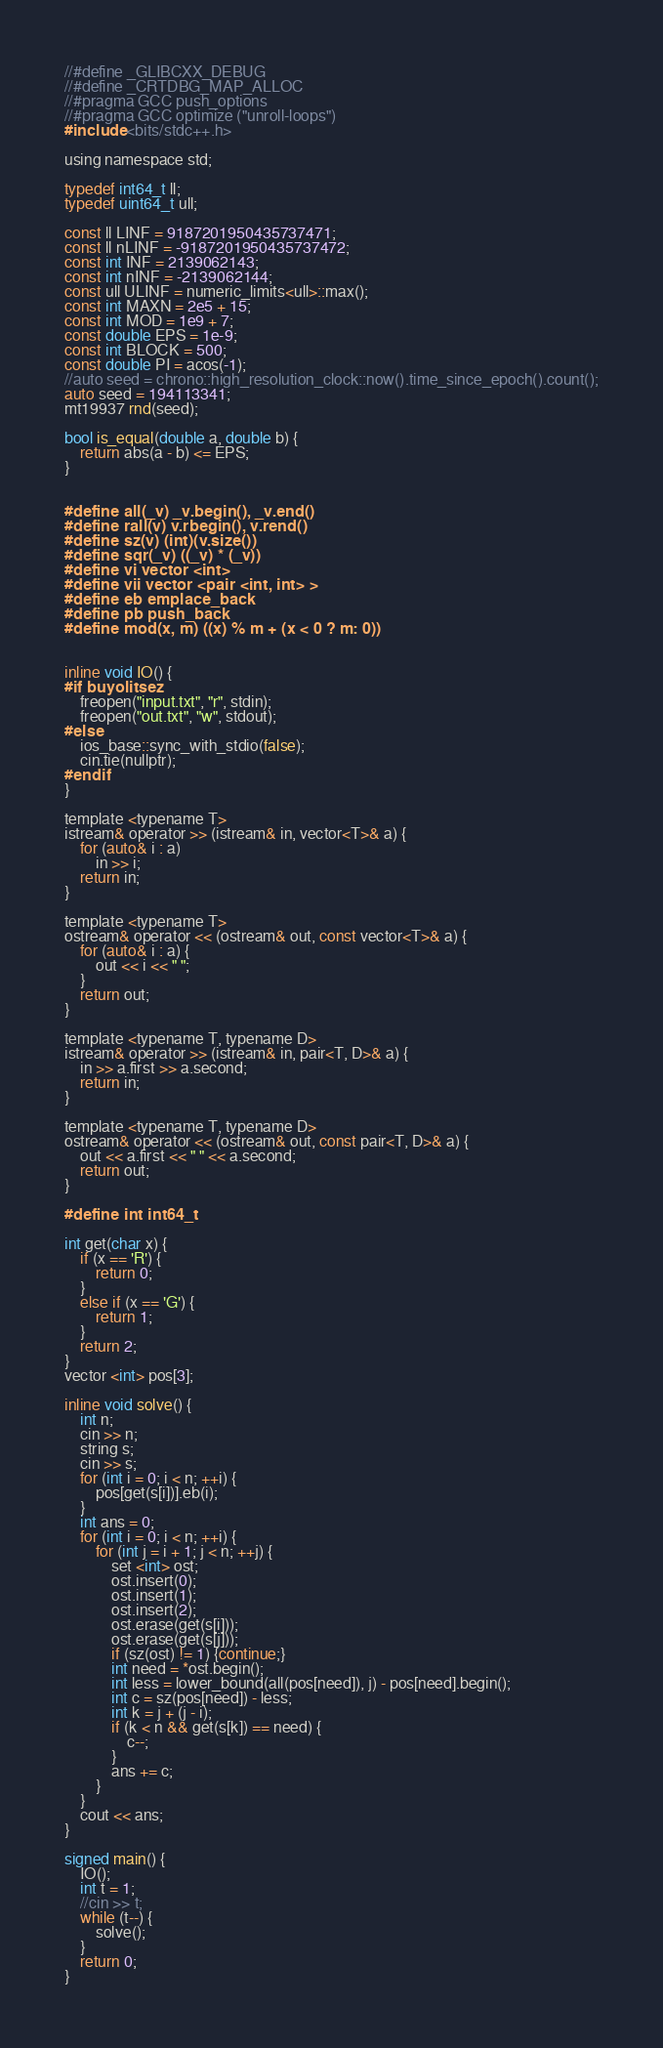Convert code to text. <code><loc_0><loc_0><loc_500><loc_500><_C_>//#define _GLIBCXX_DEBUG
//#define _CRTDBG_MAP_ALLOC
//#pragma GCC push_options
//#pragma GCC optimize ("unroll-loops")
#include <bits/stdc++.h>

using namespace std;

typedef int64_t ll;
typedef uint64_t ull;

const ll LINF = 9187201950435737471;
const ll nLINF = -9187201950435737472;
const int INF = 2139062143;
const int nINF = -2139062144;
const ull ULINF = numeric_limits<ull>::max();
const int MAXN = 2e5 + 15;
const int MOD = 1e9 + 7;
const double EPS = 1e-9;
const int BLOCK = 500;
const double PI = acos(-1);
//auto seed = chrono::high_resolution_clock::now().time_since_epoch().count();
auto seed = 194113341;
mt19937 rnd(seed);

bool is_equal(double a, double b) {
    return abs(a - b) <= EPS;
}


#define all(_v) _v.begin(), _v.end()
#define rall(v) v.rbegin(), v.rend()
#define sz(v) (int)(v.size())
#define sqr(_v) ((_v) * (_v))
#define vi vector <int>
#define vii vector <pair <int, int> >
#define eb emplace_back
#define pb push_back
#define mod(x, m) ((x) % m + (x < 0 ? m: 0))


inline void IO() {
#if buyolitsez
    freopen("input.txt", "r", stdin);
    freopen("out.txt", "w", stdout);
#else
    ios_base::sync_with_stdio(false);
    cin.tie(nullptr);
#endif
}

template <typename T>
istream& operator >> (istream& in, vector<T>& a) {
    for (auto& i : a)
        in >> i;
    return in;
}

template <typename T>
ostream& operator << (ostream& out, const vector<T>& a) {
    for (auto& i : a) {
        out << i << " ";
    }
    return out;
}

template <typename T, typename D>
istream& operator >> (istream& in, pair<T, D>& a) {
    in >> a.first >> a.second;
    return in;
}

template <typename T, typename D>
ostream& operator << (ostream& out, const pair<T, D>& a) {
    out << a.first << " " << a.second;
    return out;
}

#define int int64_t

int get(char x) {
    if (x == 'R') {
        return 0;
    }
    else if (x == 'G') {
        return 1;
    }
    return 2;
}
vector <int> pos[3];

inline void solve() {
    int n;
    cin >> n;
    string s;
    cin >> s;
    for (int i = 0; i < n; ++i) {
        pos[get(s[i])].eb(i);
    }
    int ans = 0;
    for (int i = 0; i < n; ++i) {
        for (int j = i + 1; j < n; ++j) {
            set <int> ost;
            ost.insert(0);
            ost.insert(1);
            ost.insert(2);
            ost.erase(get(s[i]));
            ost.erase(get(s[j]));
            if (sz(ost) != 1) {continue;}
            int need = *ost.begin();
            int less = lower_bound(all(pos[need]), j) - pos[need].begin();
            int c = sz(pos[need]) - less;
            int k = j + (j - i);
            if (k < n && get(s[k]) == need) {
                c--;
            }
            ans += c;
        }
    }
    cout << ans;
}

signed main() {
    IO();
    int t = 1;
    //cin >> t;
    while (t--) {
        solve();
    }
    return 0;
}</code> 